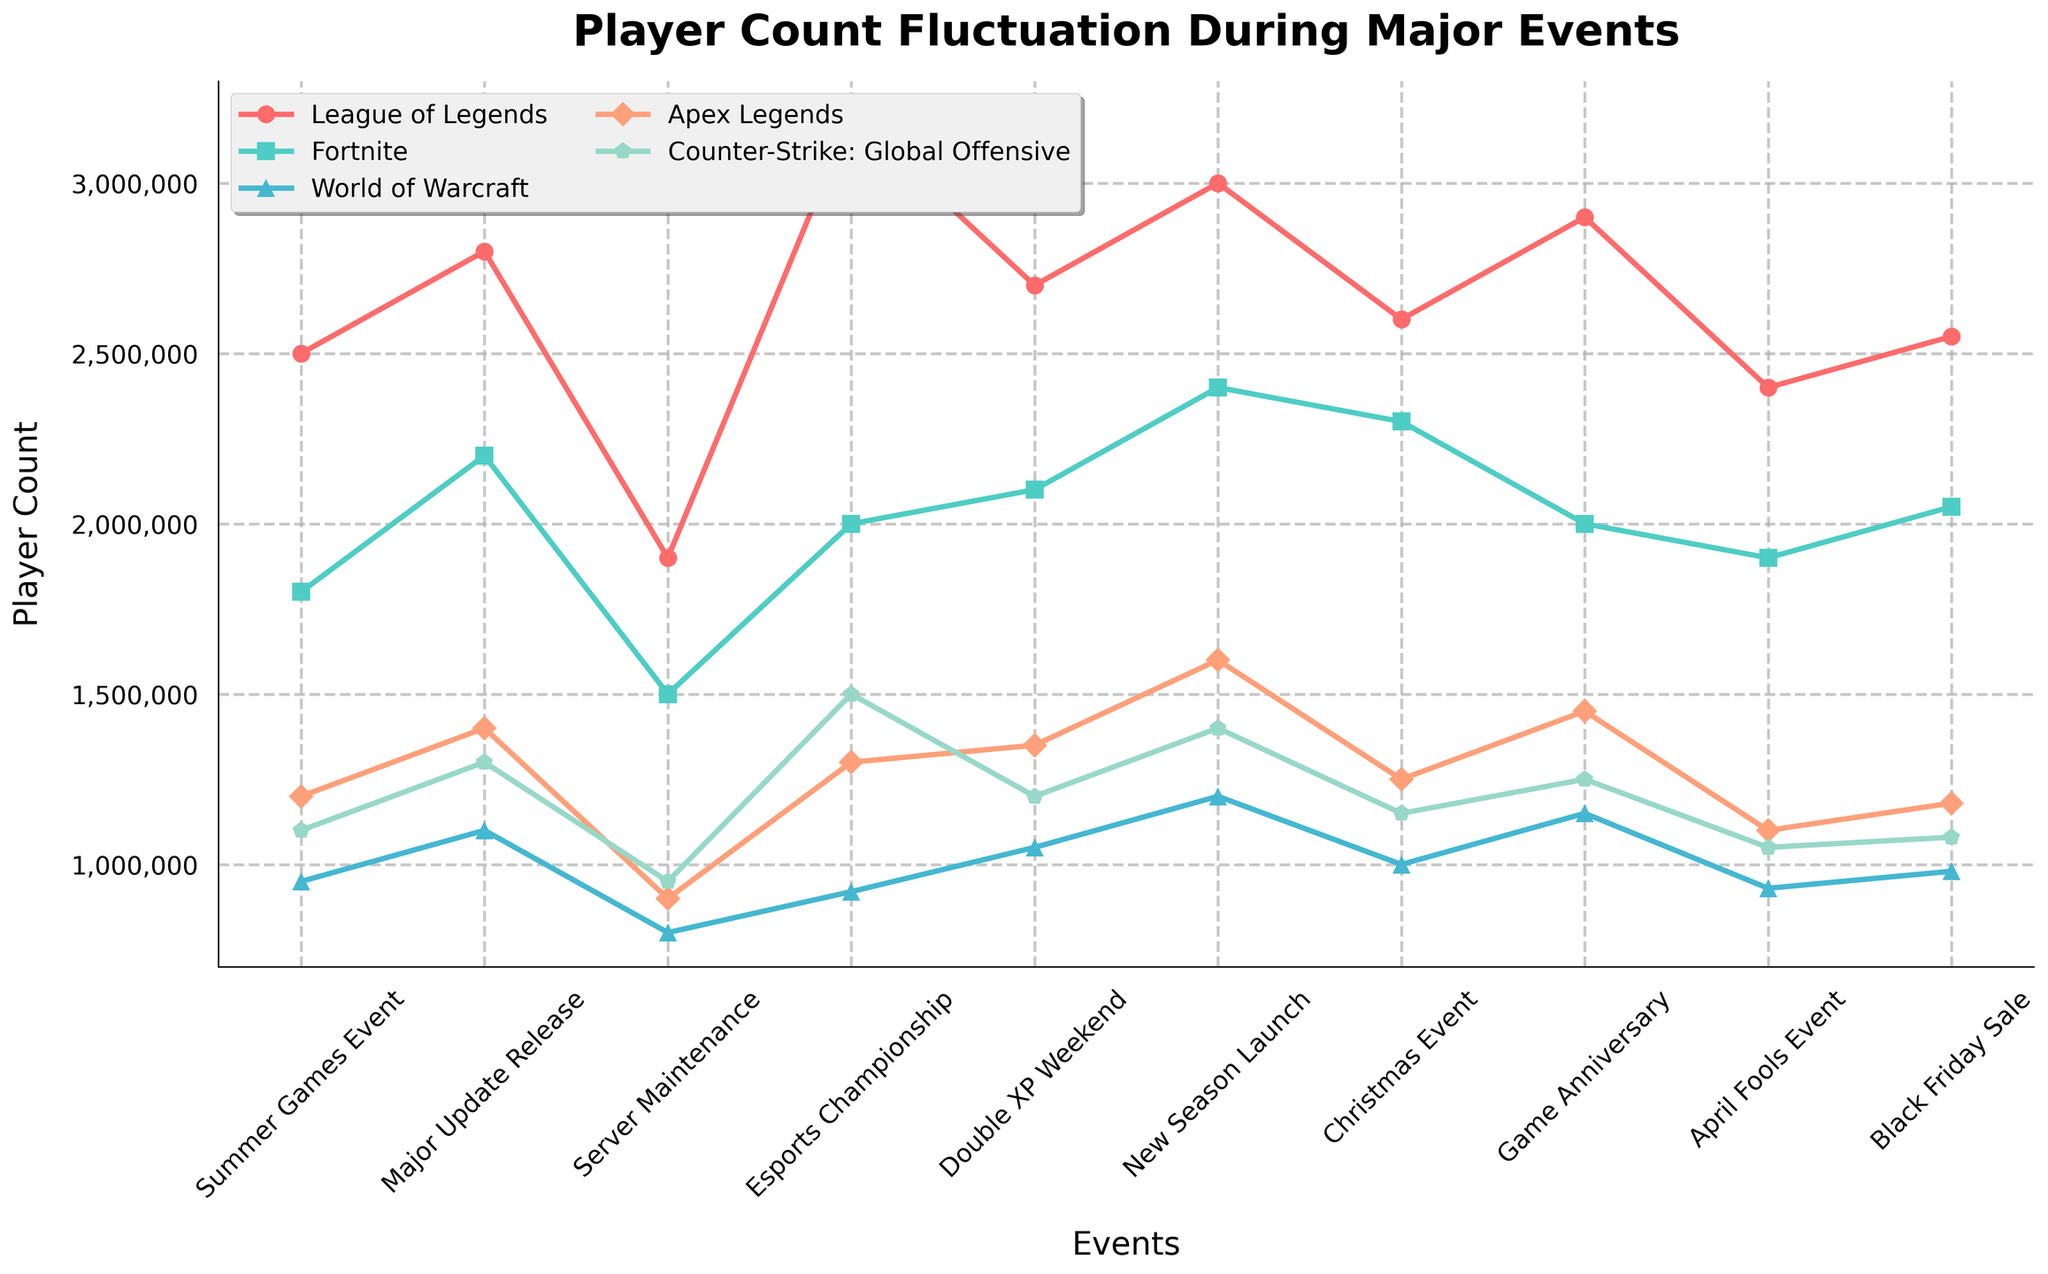Which game saw the highest player count during the New Season Launch event? Look for the highest peak in the New Season Launch column. League of Legends has the highest player count of 3,000,000.
Answer: League of Legends How much did the player count for Fortnite increase from the Summer Games Event to the Major Update Release? Check the player count for Fortnite during both events. The increase is from 1,800,000 to 2,200,000. The difference is 2,200,000 - 1,800,000 = 400,000.
Answer: 400,000 Which event caused the lowest player count for World of Warcraft? Check the lowest value in World of Warcraft’s line for all events. Server Maintenance had the lowest count at 800,000.
Answer: Server Maintenance During which event did Apex Legends have a higher player count than Counter-Strike: Global Offensive? Compare Apex Legends and Counter-Strike: Global Offensive player counts for each event. Apex Legends had higher player counts during Summer Games Event, Major Update Release, Esports Championship, Double XP Weekend, New Season Launch, Christmas Event, and Game Anniversary.
Answer: Several events (Summer Games Event, Major Update Release, Esports Championship, Double XP Weekend, New Season Launch, Christmas Event, Game Anniversary) What is the average player count for League of Legends over all events? Add all the player counts for League of Legends and divide by the number of events. Sum is 25,350,000; the number of events is 10. Average = 25,350,000 / 10 = 2,535,000.
Answer: 2,535,000 During the Esports Championship, how much greater was the player count of League of Legends compared to World of Warcraft? Subtract World of Warcraft’s player count from League of Legends' player count during the Esports Championship. 3,200,000 - 920,000 = 2,280,000.
Answer: 2,280,000 Which event led to the highest increase in player count for Apex Legends compared to the previous event? Check the difference in player counts for Apex Legends between consecutive events. Double XP Weekend had the highest increase from Server Maintenance (1,050,000 - 900,000 = 150,000).
Answer: Double XP Weekend What was the total player count for Counter-Strike: Global Offensive during the Black Friday Sale and April Fools Event combined? Add the player count for Counter-Strike: Global Offensive during both events. 1,050,000 (April Fools Event) + 1,080,000 (Black Friday Sale) = 2,130,000.
Answer: 2,130,000 